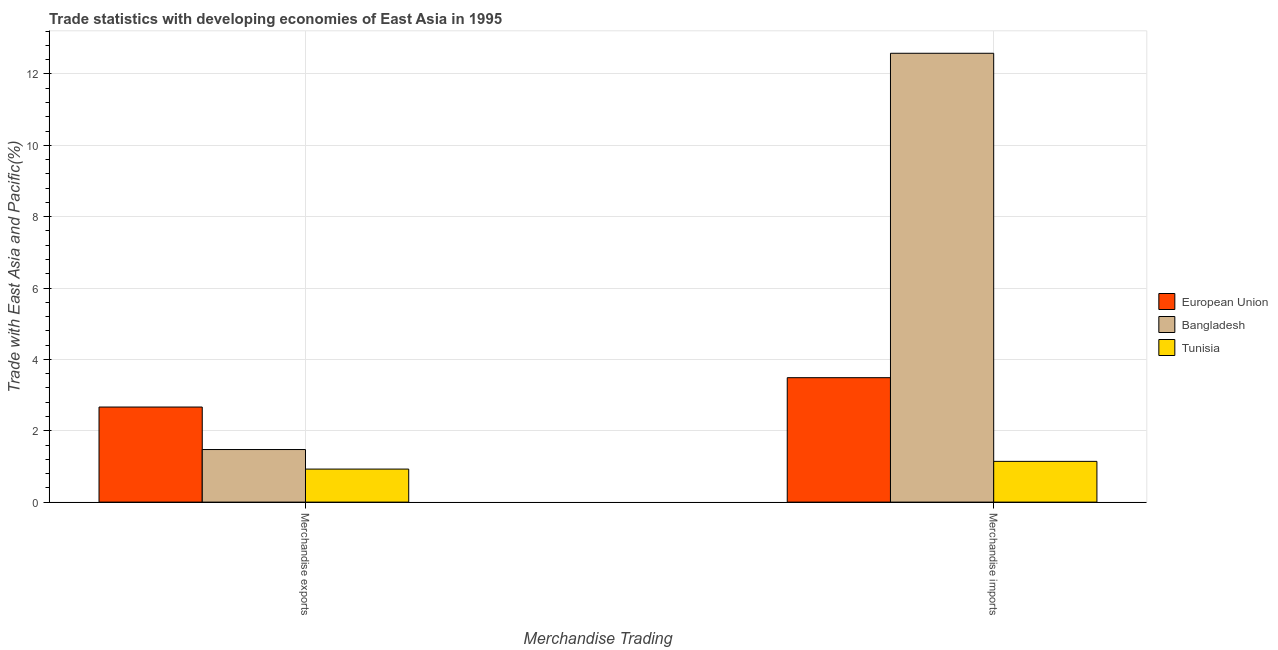How many groups of bars are there?
Give a very brief answer. 2. Are the number of bars per tick equal to the number of legend labels?
Your response must be concise. Yes. How many bars are there on the 1st tick from the left?
Provide a succinct answer. 3. How many bars are there on the 1st tick from the right?
Keep it short and to the point. 3. What is the label of the 1st group of bars from the left?
Your answer should be compact. Merchandise exports. What is the merchandise imports in European Union?
Give a very brief answer. 3.49. Across all countries, what is the maximum merchandise imports?
Offer a terse response. 12.58. Across all countries, what is the minimum merchandise imports?
Your response must be concise. 1.14. In which country was the merchandise exports minimum?
Keep it short and to the point. Tunisia. What is the total merchandise exports in the graph?
Provide a short and direct response. 5.07. What is the difference between the merchandise exports in Bangladesh and that in European Union?
Offer a very short reply. -1.19. What is the difference between the merchandise exports in European Union and the merchandise imports in Tunisia?
Ensure brevity in your answer.  1.52. What is the average merchandise exports per country?
Ensure brevity in your answer.  1.69. What is the difference between the merchandise imports and merchandise exports in Tunisia?
Your response must be concise. 0.22. What is the ratio of the merchandise imports in European Union to that in Tunisia?
Ensure brevity in your answer.  3.05. In how many countries, is the merchandise imports greater than the average merchandise imports taken over all countries?
Make the answer very short. 1. What does the 3rd bar from the left in Merchandise exports represents?
Provide a succinct answer. Tunisia. Are all the bars in the graph horizontal?
Offer a very short reply. No. Are the values on the major ticks of Y-axis written in scientific E-notation?
Provide a short and direct response. No. Does the graph contain grids?
Offer a very short reply. Yes. How many legend labels are there?
Provide a succinct answer. 3. How are the legend labels stacked?
Provide a short and direct response. Vertical. What is the title of the graph?
Offer a terse response. Trade statistics with developing economies of East Asia in 1995. What is the label or title of the X-axis?
Offer a very short reply. Merchandise Trading. What is the label or title of the Y-axis?
Ensure brevity in your answer.  Trade with East Asia and Pacific(%). What is the Trade with East Asia and Pacific(%) in European Union in Merchandise exports?
Give a very brief answer. 2.67. What is the Trade with East Asia and Pacific(%) in Bangladesh in Merchandise exports?
Ensure brevity in your answer.  1.47. What is the Trade with East Asia and Pacific(%) of Tunisia in Merchandise exports?
Provide a succinct answer. 0.93. What is the Trade with East Asia and Pacific(%) of European Union in Merchandise imports?
Keep it short and to the point. 3.49. What is the Trade with East Asia and Pacific(%) in Bangladesh in Merchandise imports?
Your answer should be very brief. 12.58. What is the Trade with East Asia and Pacific(%) in Tunisia in Merchandise imports?
Your response must be concise. 1.14. Across all Merchandise Trading, what is the maximum Trade with East Asia and Pacific(%) in European Union?
Keep it short and to the point. 3.49. Across all Merchandise Trading, what is the maximum Trade with East Asia and Pacific(%) in Bangladesh?
Make the answer very short. 12.58. Across all Merchandise Trading, what is the maximum Trade with East Asia and Pacific(%) in Tunisia?
Your response must be concise. 1.14. Across all Merchandise Trading, what is the minimum Trade with East Asia and Pacific(%) of European Union?
Your answer should be compact. 2.67. Across all Merchandise Trading, what is the minimum Trade with East Asia and Pacific(%) in Bangladesh?
Your answer should be very brief. 1.47. Across all Merchandise Trading, what is the minimum Trade with East Asia and Pacific(%) of Tunisia?
Your answer should be compact. 0.93. What is the total Trade with East Asia and Pacific(%) in European Union in the graph?
Keep it short and to the point. 6.15. What is the total Trade with East Asia and Pacific(%) in Bangladesh in the graph?
Provide a short and direct response. 14.05. What is the total Trade with East Asia and Pacific(%) of Tunisia in the graph?
Your response must be concise. 2.07. What is the difference between the Trade with East Asia and Pacific(%) of European Union in Merchandise exports and that in Merchandise imports?
Your response must be concise. -0.82. What is the difference between the Trade with East Asia and Pacific(%) in Bangladesh in Merchandise exports and that in Merchandise imports?
Give a very brief answer. -11.11. What is the difference between the Trade with East Asia and Pacific(%) in Tunisia in Merchandise exports and that in Merchandise imports?
Keep it short and to the point. -0.22. What is the difference between the Trade with East Asia and Pacific(%) of European Union in Merchandise exports and the Trade with East Asia and Pacific(%) of Bangladesh in Merchandise imports?
Give a very brief answer. -9.92. What is the difference between the Trade with East Asia and Pacific(%) of European Union in Merchandise exports and the Trade with East Asia and Pacific(%) of Tunisia in Merchandise imports?
Offer a very short reply. 1.52. What is the difference between the Trade with East Asia and Pacific(%) in Bangladesh in Merchandise exports and the Trade with East Asia and Pacific(%) in Tunisia in Merchandise imports?
Offer a terse response. 0.33. What is the average Trade with East Asia and Pacific(%) in European Union per Merchandise Trading?
Your answer should be compact. 3.08. What is the average Trade with East Asia and Pacific(%) of Bangladesh per Merchandise Trading?
Give a very brief answer. 7.03. What is the average Trade with East Asia and Pacific(%) in Tunisia per Merchandise Trading?
Give a very brief answer. 1.03. What is the difference between the Trade with East Asia and Pacific(%) of European Union and Trade with East Asia and Pacific(%) of Bangladesh in Merchandise exports?
Offer a terse response. 1.19. What is the difference between the Trade with East Asia and Pacific(%) of European Union and Trade with East Asia and Pacific(%) of Tunisia in Merchandise exports?
Your response must be concise. 1.74. What is the difference between the Trade with East Asia and Pacific(%) in Bangladesh and Trade with East Asia and Pacific(%) in Tunisia in Merchandise exports?
Make the answer very short. 0.55. What is the difference between the Trade with East Asia and Pacific(%) of European Union and Trade with East Asia and Pacific(%) of Bangladesh in Merchandise imports?
Provide a short and direct response. -9.09. What is the difference between the Trade with East Asia and Pacific(%) of European Union and Trade with East Asia and Pacific(%) of Tunisia in Merchandise imports?
Offer a very short reply. 2.35. What is the difference between the Trade with East Asia and Pacific(%) of Bangladesh and Trade with East Asia and Pacific(%) of Tunisia in Merchandise imports?
Offer a terse response. 11.44. What is the ratio of the Trade with East Asia and Pacific(%) of European Union in Merchandise exports to that in Merchandise imports?
Provide a short and direct response. 0.76. What is the ratio of the Trade with East Asia and Pacific(%) in Bangladesh in Merchandise exports to that in Merchandise imports?
Offer a terse response. 0.12. What is the ratio of the Trade with East Asia and Pacific(%) in Tunisia in Merchandise exports to that in Merchandise imports?
Give a very brief answer. 0.81. What is the difference between the highest and the second highest Trade with East Asia and Pacific(%) of European Union?
Your response must be concise. 0.82. What is the difference between the highest and the second highest Trade with East Asia and Pacific(%) in Bangladesh?
Provide a short and direct response. 11.11. What is the difference between the highest and the second highest Trade with East Asia and Pacific(%) in Tunisia?
Your answer should be compact. 0.22. What is the difference between the highest and the lowest Trade with East Asia and Pacific(%) in European Union?
Provide a succinct answer. 0.82. What is the difference between the highest and the lowest Trade with East Asia and Pacific(%) in Bangladesh?
Provide a succinct answer. 11.11. What is the difference between the highest and the lowest Trade with East Asia and Pacific(%) in Tunisia?
Your answer should be very brief. 0.22. 